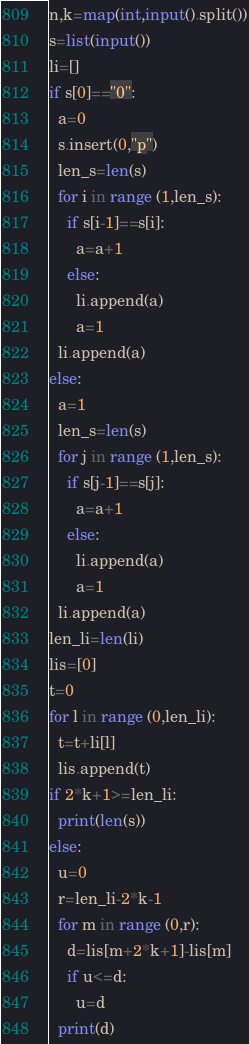Convert code to text. <code><loc_0><loc_0><loc_500><loc_500><_Python_>n,k=map(int,input().split())
s=list(input())
li=[]
if s[0]=="0":
  a=0
  s.insert(0,"p")
  len_s=len(s)
  for i in range (1,len_s):
    if s[i-1]==s[i]:
      a=a+1
    else:
      li.append(a)
      a=1
  li.append(a)
else:
  a=1
  len_s=len(s)
  for j in range (1,len_s):
    if s[j-1]==s[j]:
      a=a+1
    else:
      li.append(a)
      a=1
  li.append(a)
len_li=len(li)
lis=[0]
t=0
for l in range (0,len_li):
  t=t+li[l]
  lis.append(t)
if 2*k+1>=len_li:
  print(len(s))
else:
  u=0
  r=len_li-2*k-1
  for m in range (0,r):
    d=lis[m+2*k+1]-lis[m]
    if u<=d:
      u=d
  print(d)</code> 